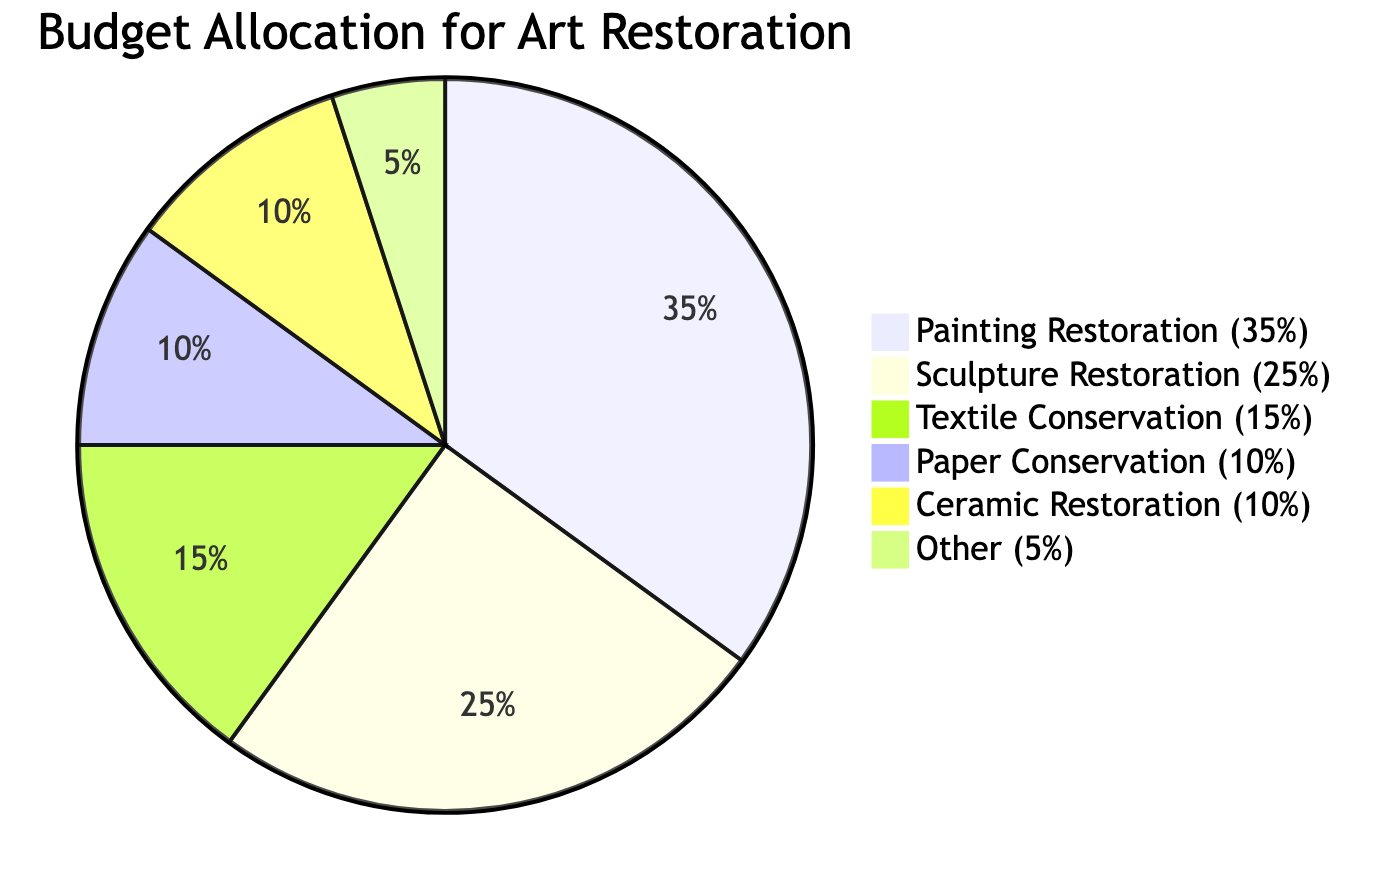What percentage of the budget is allocated to Painting Restoration? The diagram specifies that Painting Restoration is allocated 35% of the total budget as indicated directly on the pie chart.
Answer: 35% What type of restoration receives the least funding? By comparing the percentages shown in the pie chart, Other receives the least funding at 5%.
Answer: Other How many restoration categories are represented in the diagram? The pie chart lists six distinct categories for restoration, each associated with a specific percentage of the budget.
Answer: 6 What is the total percentage allocated to Sculpture and Textile? The chart shows Sculpture Restoration is 25% and Textile Conservation is 15%. Adding these two values together gives 25% + 15% = 40%.
Answer: 40% Which restoration type has a larger budget, Paper Conservation or Ceramic Restoration? The diagram indicates that Paper Conservation has a budget of 10%, while Ceramic Restoration also has a budget of 10%. Therefore, both categories have equal allocations.
Answer: Equal What is the proportion of the budget allocated to combined Painting and Sculpture restorations? Painting Restoration is 35% and Sculpture Restoration is 25%. To find the total, you add both percentages: 35% + 25% = 60%.
Answer: 60% What fraction of the budget is allocated to Textile Conservation compared to the total budget? Textile Conservation is allocated 15% of the total budget, which can be expressed as 15 out of 100, or simplified to 3/20 when converted to a fraction.
Answer: 3/20 How much of the budget is not allocated to Painting Restoration? With Painting Restoration at 35%, the remaining portion of the budget would be 100% - 35% = 65%.
Answer: 65% 